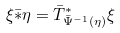Convert formula to latex. <formula><loc_0><loc_0><loc_500><loc_500>\xi \bar { * } \eta = \bar { T } ^ { * } _ { \bar { \Psi } ^ { - 1 } ( \eta ) } \xi</formula> 